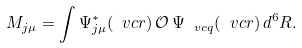<formula> <loc_0><loc_0><loc_500><loc_500>M _ { j \mu } = \int \Psi ^ { * } _ { j \mu } ( \ v c r ) \, \mathcal { O } \, \Psi _ { \ v c q } ( \ v c r ) \, d ^ { 6 } R .</formula> 